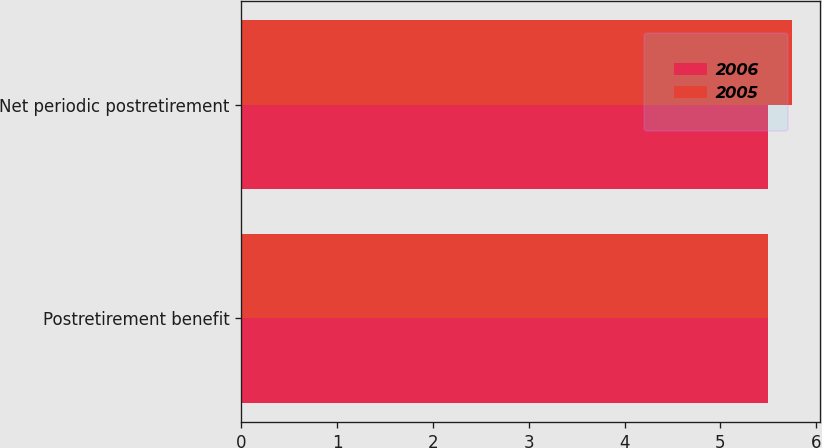Convert chart to OTSL. <chart><loc_0><loc_0><loc_500><loc_500><stacked_bar_chart><ecel><fcel>Postretirement benefit<fcel>Net periodic postretirement<nl><fcel>2006<fcel>5.5<fcel>5.5<nl><fcel>2005<fcel>5.5<fcel>5.75<nl></chart> 